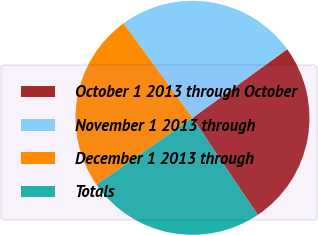Convert chart to OTSL. <chart><loc_0><loc_0><loc_500><loc_500><pie_chart><fcel>October 1 2013 through October<fcel>November 1 2013 through<fcel>December 1 2013 through<fcel>Totals<nl><fcel>25.56%<fcel>25.05%<fcel>24.65%<fcel>24.74%<nl></chart> 